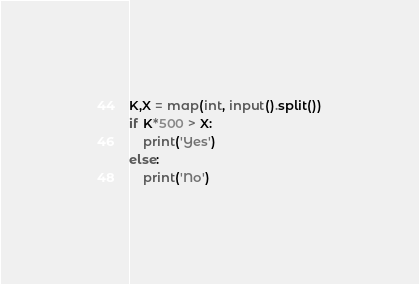Convert code to text. <code><loc_0><loc_0><loc_500><loc_500><_Python_>K,X = map(int, input().split())
if K*500 > X:
	print('Yes')
else:
	print('No')</code> 